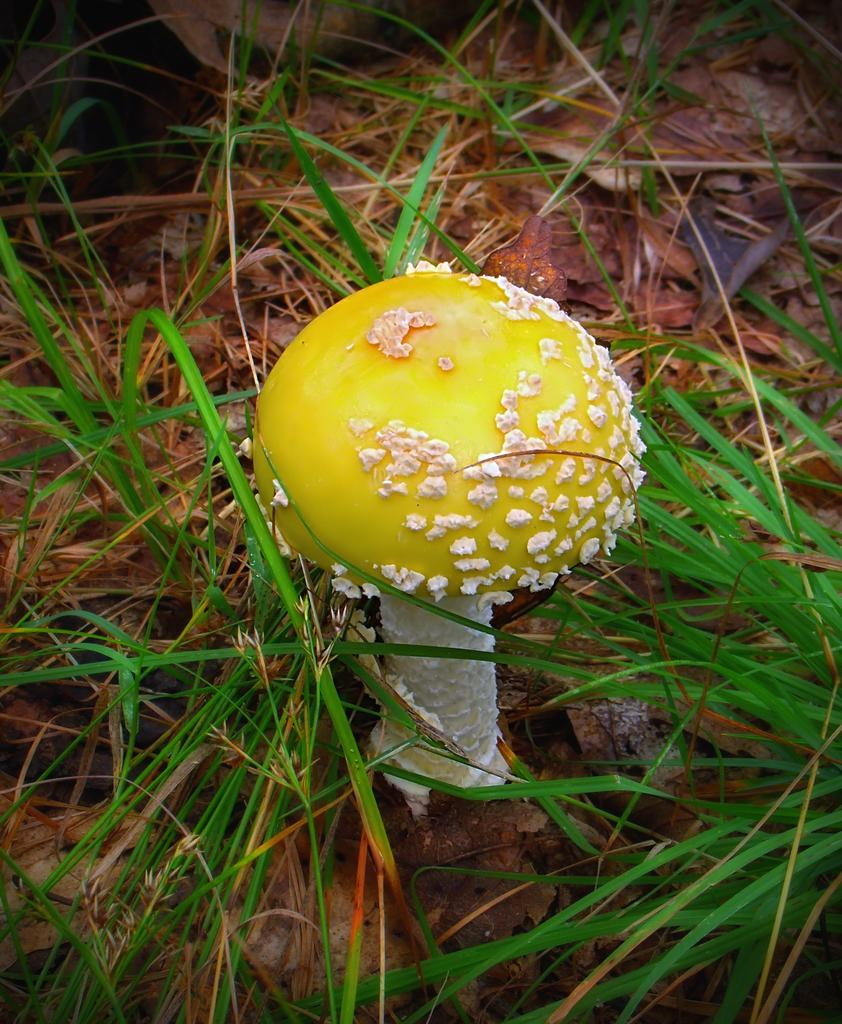What type of plant can be seen in the image? There is a mushroom in the image. What type of vegetation is present on the ground in the image? There is grass on the ground in the image. What date is marked on the calendar in the image? There is no calendar present in the image. What type of cleaning tool is visible in the image? There is no cleaning tool, such as a sponge, present in the image. 